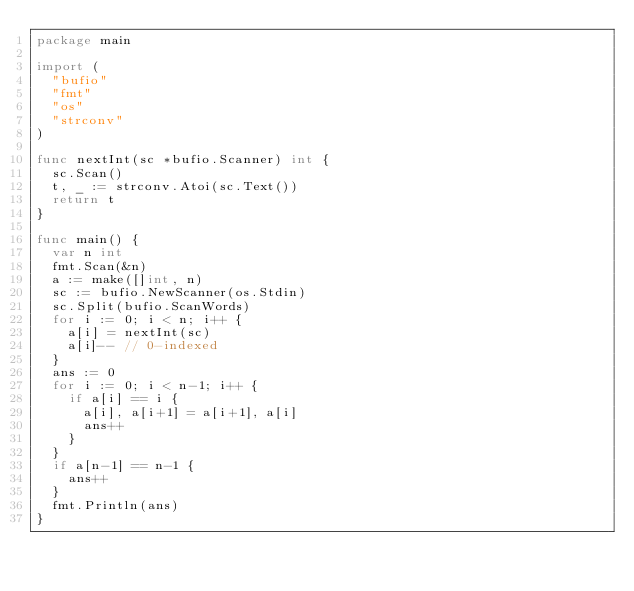Convert code to text. <code><loc_0><loc_0><loc_500><loc_500><_Go_>package main

import (
	"bufio"
	"fmt"
	"os"
	"strconv"
)

func nextInt(sc *bufio.Scanner) int {
	sc.Scan()
	t, _ := strconv.Atoi(sc.Text())
	return t
}

func main() {
	var n int
	fmt.Scan(&n)
	a := make([]int, n)
	sc := bufio.NewScanner(os.Stdin)
	sc.Split(bufio.ScanWords)
	for i := 0; i < n; i++ {
		a[i] = nextInt(sc)
		a[i]-- // 0-indexed
	}
	ans := 0
	for i := 0; i < n-1; i++ {
		if a[i] == i {
			a[i], a[i+1] = a[i+1], a[i]
			ans++
		}
	}
	if a[n-1] == n-1 {
		ans++
	}
	fmt.Println(ans)
}
</code> 